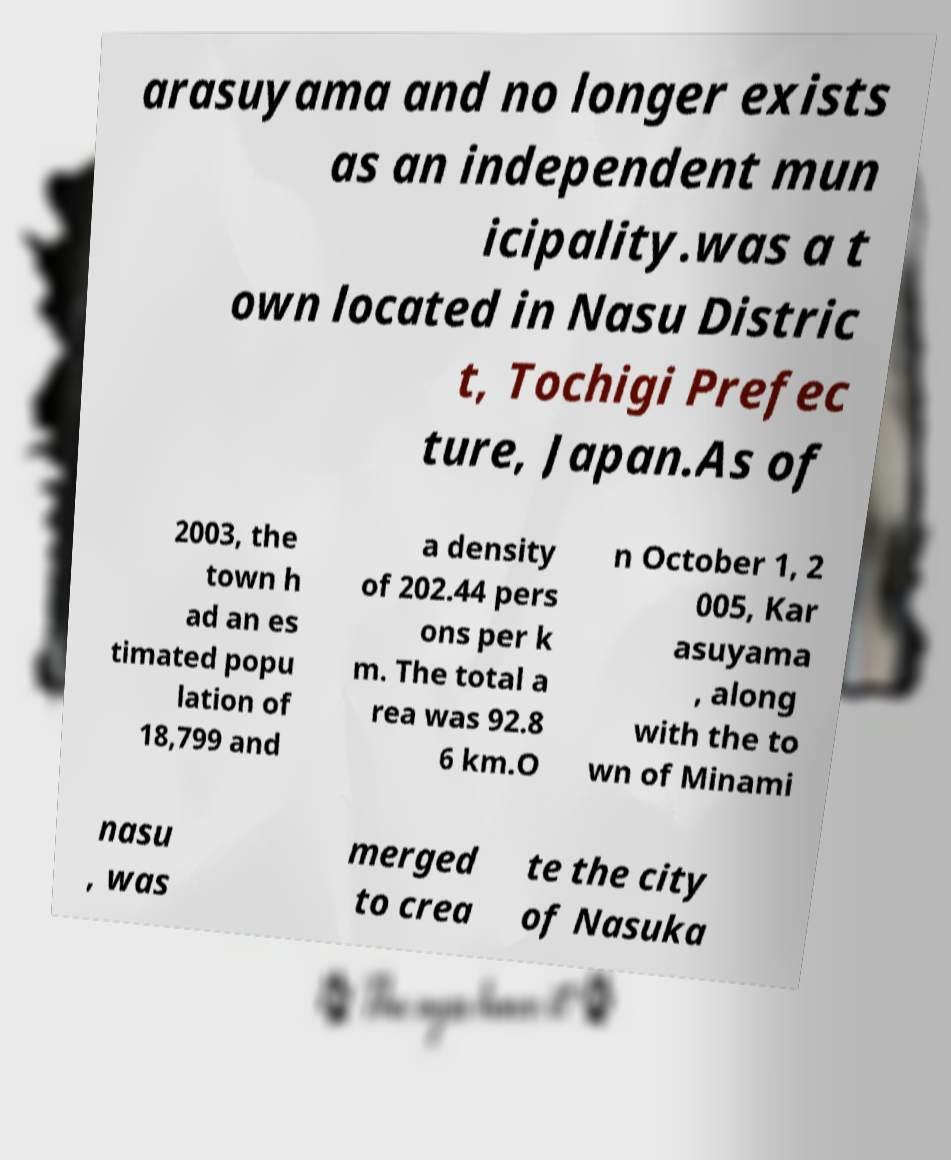For documentation purposes, I need the text within this image transcribed. Could you provide that? arasuyama and no longer exists as an independent mun icipality.was a t own located in Nasu Distric t, Tochigi Prefec ture, Japan.As of 2003, the town h ad an es timated popu lation of 18,799 and a density of 202.44 pers ons per k m. The total a rea was 92.8 6 km.O n October 1, 2 005, Kar asuyama , along with the to wn of Minami nasu , was merged to crea te the city of Nasuka 